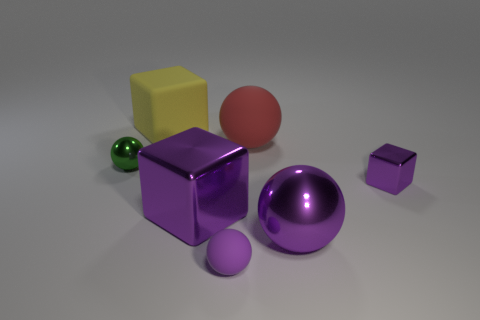Add 1 matte cubes. How many objects exist? 8 Subtract all purple balls. How many balls are left? 2 Subtract all large purple metal spheres. How many spheres are left? 3 Subtract 1 cubes. How many cubes are left? 2 Subtract all balls. Subtract all big cyan cylinders. How many objects are left? 3 Add 3 green metallic objects. How many green metallic objects are left? 4 Add 7 purple metallic cubes. How many purple metallic cubes exist? 9 Subtract 0 brown spheres. How many objects are left? 7 Subtract all balls. How many objects are left? 3 Subtract all cyan spheres. Subtract all red cubes. How many spheres are left? 4 